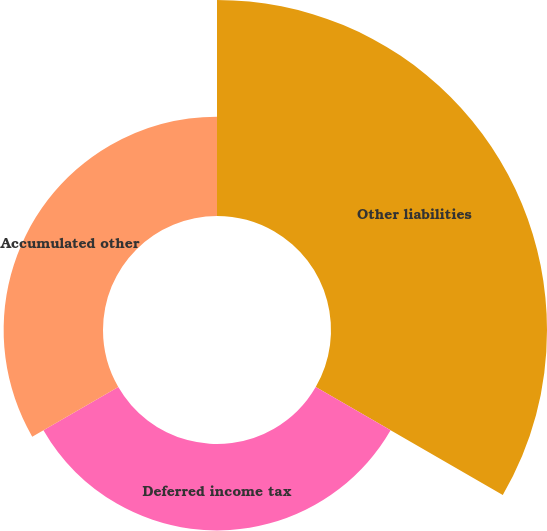<chart> <loc_0><loc_0><loc_500><loc_500><pie_chart><fcel>Other liabilities<fcel>Deferred income tax<fcel>Accumulated other<nl><fcel>53.76%<fcel>21.51%<fcel>24.73%<nl></chart> 